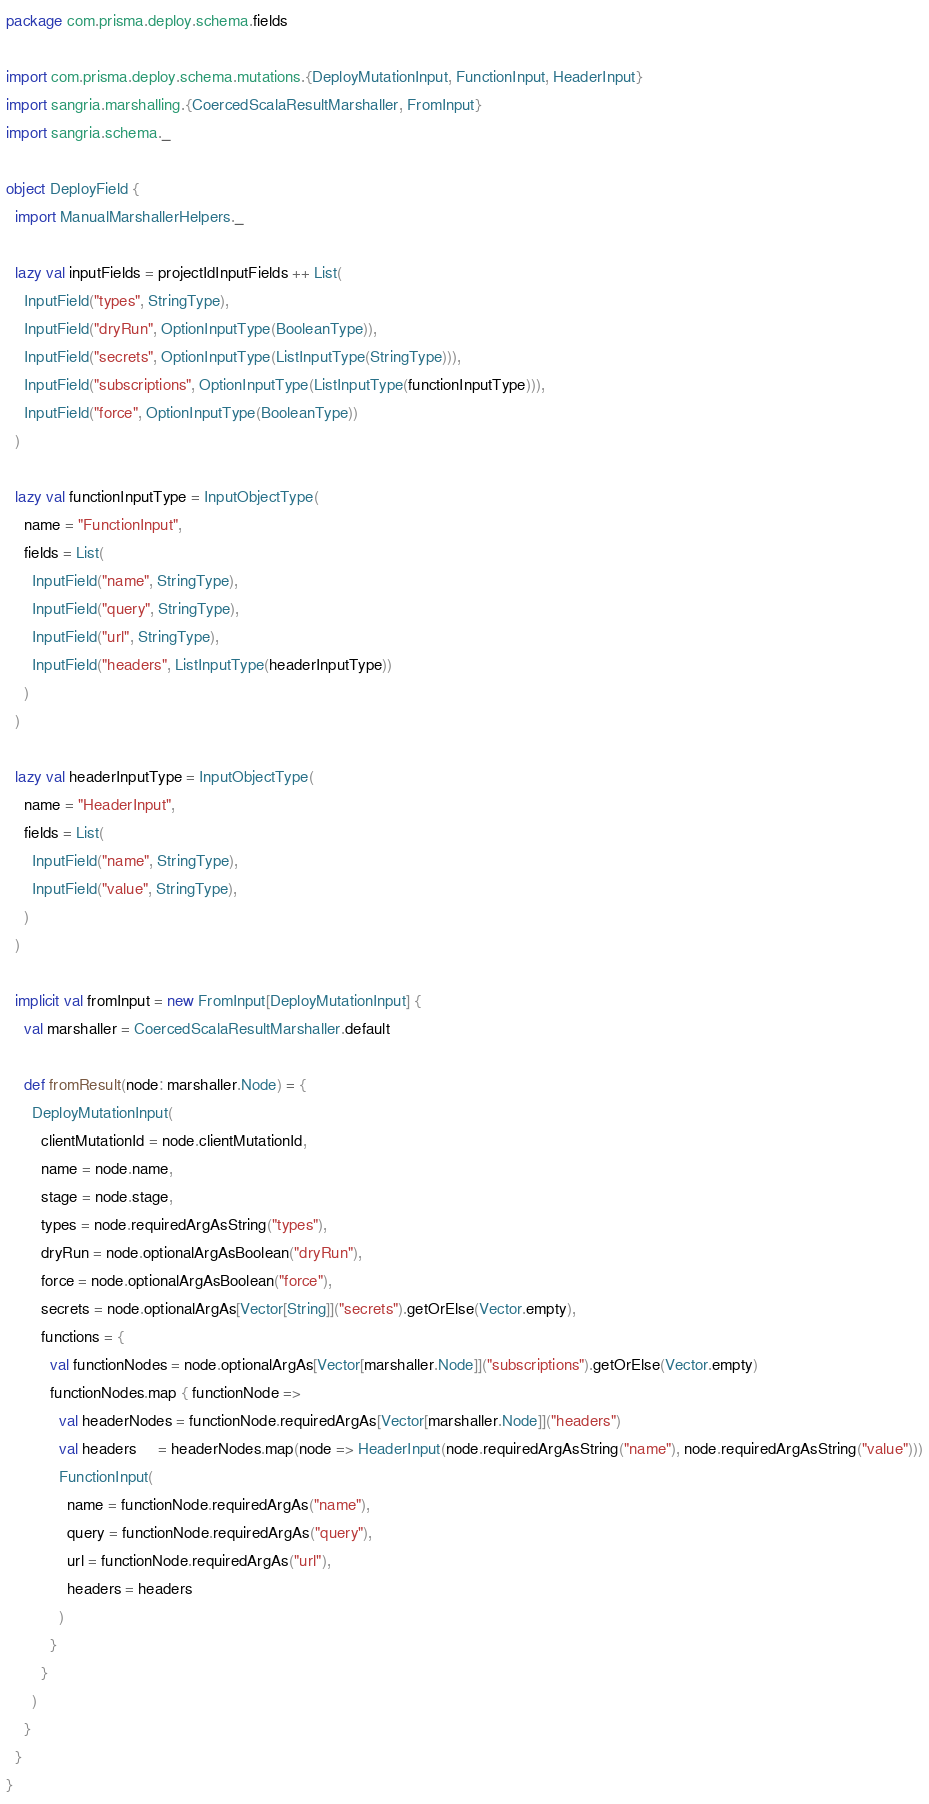Convert code to text. <code><loc_0><loc_0><loc_500><loc_500><_Scala_>package com.prisma.deploy.schema.fields

import com.prisma.deploy.schema.mutations.{DeployMutationInput, FunctionInput, HeaderInput}
import sangria.marshalling.{CoercedScalaResultMarshaller, FromInput}
import sangria.schema._

object DeployField {
  import ManualMarshallerHelpers._

  lazy val inputFields = projectIdInputFields ++ List(
    InputField("types", StringType),
    InputField("dryRun", OptionInputType(BooleanType)),
    InputField("secrets", OptionInputType(ListInputType(StringType))),
    InputField("subscriptions", OptionInputType(ListInputType(functionInputType))),
    InputField("force", OptionInputType(BooleanType))
  )

  lazy val functionInputType = InputObjectType(
    name = "FunctionInput",
    fields = List(
      InputField("name", StringType),
      InputField("query", StringType),
      InputField("url", StringType),
      InputField("headers", ListInputType(headerInputType))
    )
  )

  lazy val headerInputType = InputObjectType(
    name = "HeaderInput",
    fields = List(
      InputField("name", StringType),
      InputField("value", StringType),
    )
  )

  implicit val fromInput = new FromInput[DeployMutationInput] {
    val marshaller = CoercedScalaResultMarshaller.default

    def fromResult(node: marshaller.Node) = {
      DeployMutationInput(
        clientMutationId = node.clientMutationId,
        name = node.name,
        stage = node.stage,
        types = node.requiredArgAsString("types"),
        dryRun = node.optionalArgAsBoolean("dryRun"),
        force = node.optionalArgAsBoolean("force"),
        secrets = node.optionalArgAs[Vector[String]]("secrets").getOrElse(Vector.empty),
        functions = {
          val functionNodes = node.optionalArgAs[Vector[marshaller.Node]]("subscriptions").getOrElse(Vector.empty)
          functionNodes.map { functionNode =>
            val headerNodes = functionNode.requiredArgAs[Vector[marshaller.Node]]("headers")
            val headers     = headerNodes.map(node => HeaderInput(node.requiredArgAsString("name"), node.requiredArgAsString("value")))
            FunctionInput(
              name = functionNode.requiredArgAs("name"),
              query = functionNode.requiredArgAs("query"),
              url = functionNode.requiredArgAs("url"),
              headers = headers
            )
          }
        }
      )
    }
  }
}
</code> 